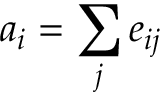<formula> <loc_0><loc_0><loc_500><loc_500>a _ { i } = \sum _ { j } e _ { i j }</formula> 